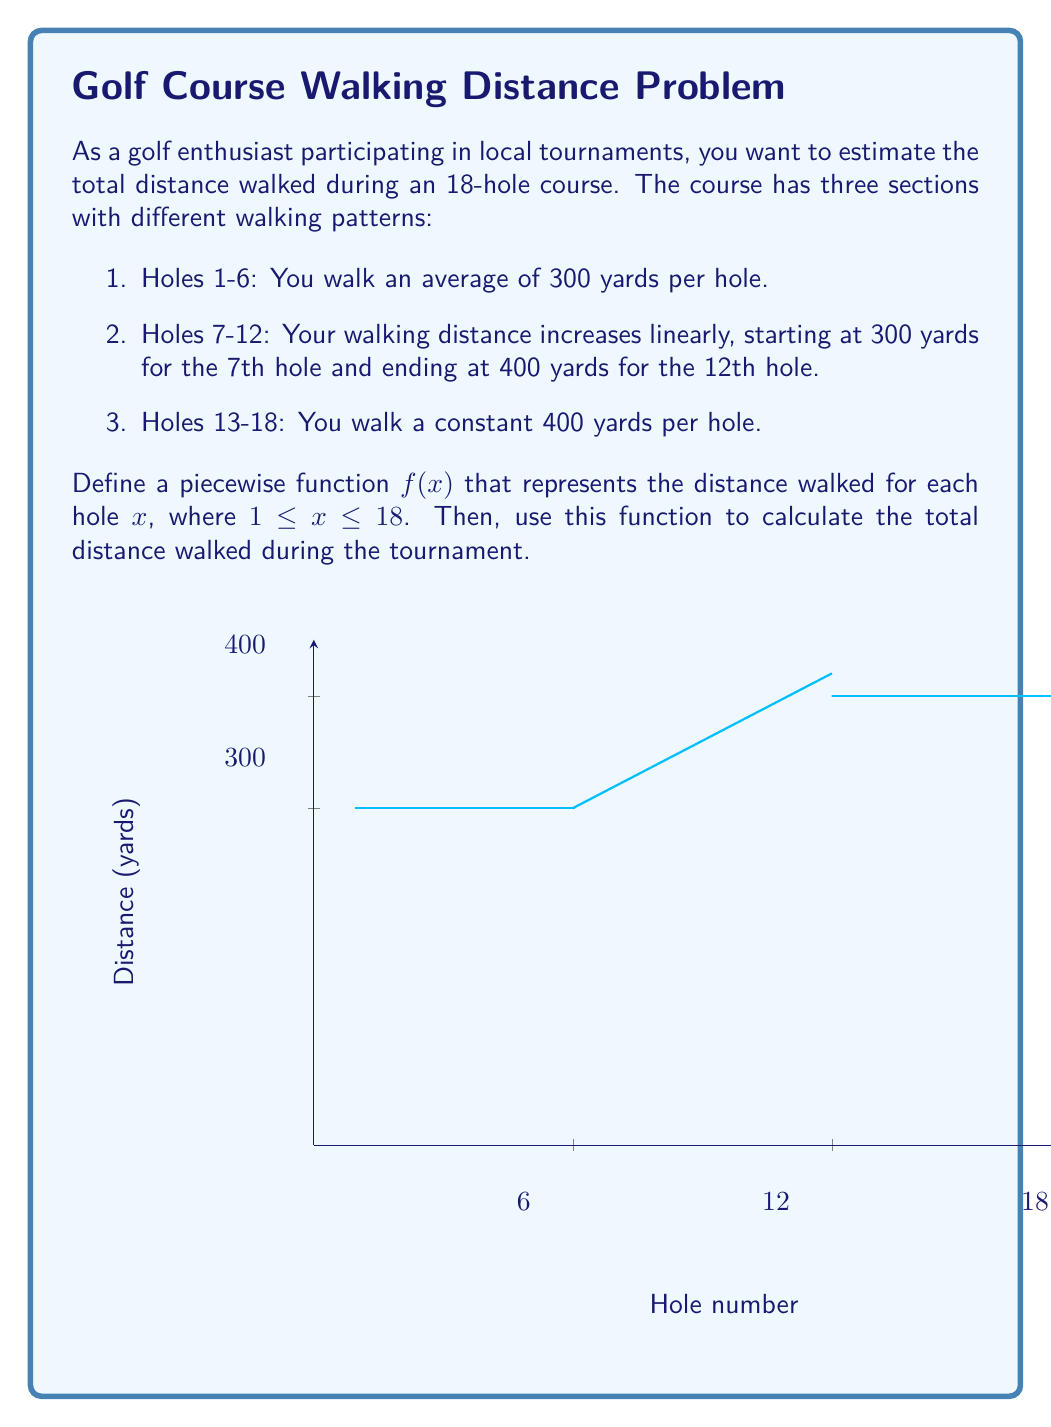Help me with this question. Let's approach this problem step-by-step:

1) First, we need to define the piecewise function $f(x)$:

   $$f(x) = \begin{cases}
   300, & 1 \leq x \leq 6 \\
   300 + 20(x-6), & 6 < x \leq 12 \\
   400, & 12 < x \leq 18
   \end{cases}$$

2) Now, to calculate the total distance, we need to sum $f(x)$ for all integer values of $x$ from 1 to 18.

3) For holes 1-6:
   Distance = $6 \times 300 = 1800$ yards

4) For holes 7-12:
   This is an arithmetic sequence with first term $a_1 = 300 + 20(7-6) = 320$ and last term $a_6 = 300 + 20(12-6) = 400$.
   Sum = $\frac{n(a_1 + a_n)}{2} = \frac{6(320 + 400)}{2} = 2160$ yards

5) For holes 13-18:
   Distance = $6 \times 400 = 2400$ yards

6) Total distance = $1800 + 2160 + 2400 = 6360$ yards

7) Convert to miles: $6360 \div 1760 \approx 3.61$ miles
Answer: $3.61$ miles 